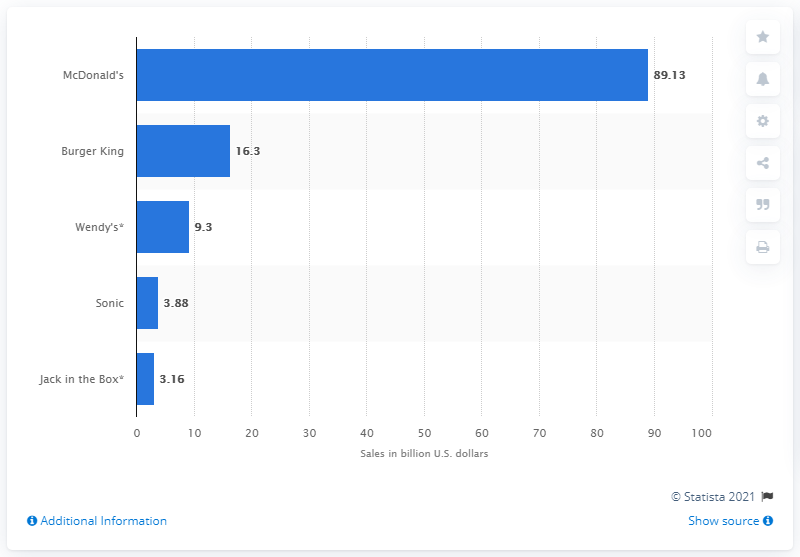Specify some key components in this picture. Burger King made $16.3 billion in revenue in 2013. McDonald's made a significant amount of money in 2013, with a total revenue of 89.13 billion US dollars. 